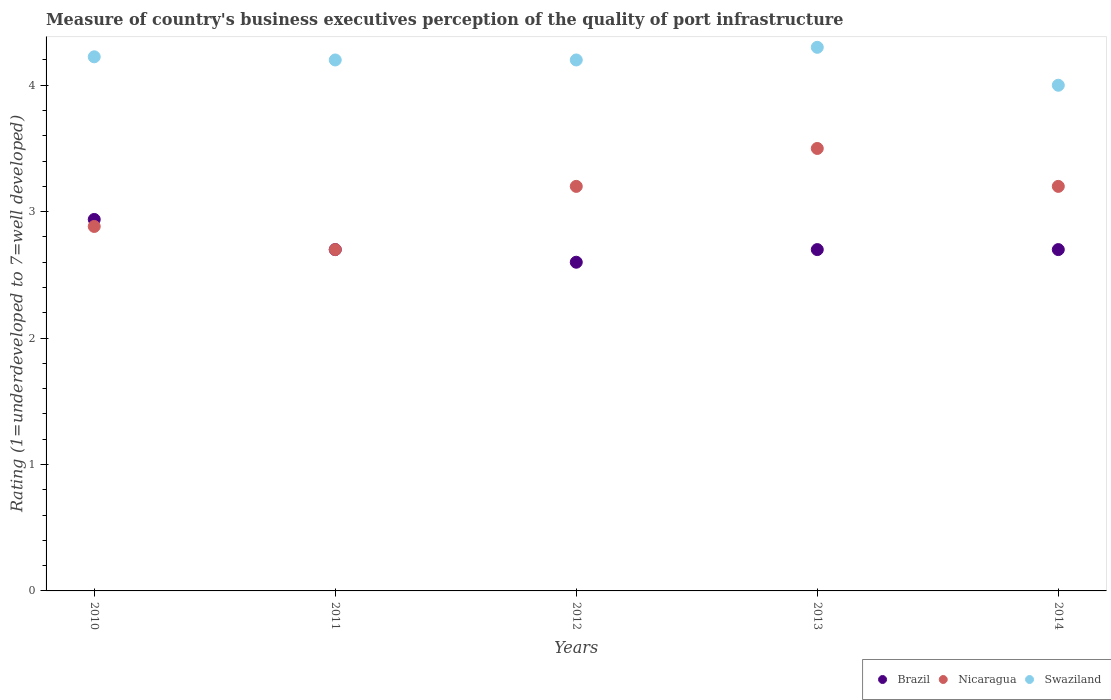How many different coloured dotlines are there?
Your response must be concise. 3. What is the ratings of the quality of port infrastructure in Brazil in 2011?
Offer a very short reply. 2.7. Across all years, what is the maximum ratings of the quality of port infrastructure in Brazil?
Provide a short and direct response. 2.94. In which year was the ratings of the quality of port infrastructure in Brazil minimum?
Ensure brevity in your answer.  2012. What is the total ratings of the quality of port infrastructure in Nicaragua in the graph?
Ensure brevity in your answer.  15.48. What is the difference between the ratings of the quality of port infrastructure in Swaziland in 2011 and that in 2013?
Make the answer very short. -0.1. What is the average ratings of the quality of port infrastructure in Brazil per year?
Your answer should be compact. 2.73. In the year 2011, what is the difference between the ratings of the quality of port infrastructure in Swaziland and ratings of the quality of port infrastructure in Brazil?
Make the answer very short. 1.5. Is the difference between the ratings of the quality of port infrastructure in Swaziland in 2011 and 2014 greater than the difference between the ratings of the quality of port infrastructure in Brazil in 2011 and 2014?
Your answer should be compact. Yes. What is the difference between the highest and the second highest ratings of the quality of port infrastructure in Brazil?
Make the answer very short. 0.24. What is the difference between the highest and the lowest ratings of the quality of port infrastructure in Swaziland?
Give a very brief answer. 0.3. Is it the case that in every year, the sum of the ratings of the quality of port infrastructure in Brazil and ratings of the quality of port infrastructure in Swaziland  is greater than the ratings of the quality of port infrastructure in Nicaragua?
Provide a succinct answer. Yes. Is the ratings of the quality of port infrastructure in Brazil strictly greater than the ratings of the quality of port infrastructure in Swaziland over the years?
Offer a very short reply. No. How many dotlines are there?
Keep it short and to the point. 3. How many years are there in the graph?
Your answer should be compact. 5. How many legend labels are there?
Provide a short and direct response. 3. How are the legend labels stacked?
Offer a very short reply. Horizontal. What is the title of the graph?
Your response must be concise. Measure of country's business executives perception of the quality of port infrastructure. What is the label or title of the X-axis?
Keep it short and to the point. Years. What is the label or title of the Y-axis?
Make the answer very short. Rating (1=underdeveloped to 7=well developed). What is the Rating (1=underdeveloped to 7=well developed) of Brazil in 2010?
Make the answer very short. 2.94. What is the Rating (1=underdeveloped to 7=well developed) of Nicaragua in 2010?
Keep it short and to the point. 2.88. What is the Rating (1=underdeveloped to 7=well developed) in Swaziland in 2010?
Your response must be concise. 4.23. What is the Rating (1=underdeveloped to 7=well developed) in Brazil in 2012?
Keep it short and to the point. 2.6. What is the Rating (1=underdeveloped to 7=well developed) in Nicaragua in 2012?
Ensure brevity in your answer.  3.2. What is the Rating (1=underdeveloped to 7=well developed) in Swaziland in 2012?
Offer a terse response. 4.2. What is the Rating (1=underdeveloped to 7=well developed) of Brazil in 2014?
Offer a terse response. 2.7. Across all years, what is the maximum Rating (1=underdeveloped to 7=well developed) in Brazil?
Give a very brief answer. 2.94. Across all years, what is the maximum Rating (1=underdeveloped to 7=well developed) in Nicaragua?
Your response must be concise. 3.5. Across all years, what is the minimum Rating (1=underdeveloped to 7=well developed) in Nicaragua?
Give a very brief answer. 2.7. What is the total Rating (1=underdeveloped to 7=well developed) in Brazil in the graph?
Your answer should be very brief. 13.64. What is the total Rating (1=underdeveloped to 7=well developed) in Nicaragua in the graph?
Your answer should be compact. 15.48. What is the total Rating (1=underdeveloped to 7=well developed) in Swaziland in the graph?
Keep it short and to the point. 20.93. What is the difference between the Rating (1=underdeveloped to 7=well developed) in Brazil in 2010 and that in 2011?
Offer a very short reply. 0.24. What is the difference between the Rating (1=underdeveloped to 7=well developed) of Nicaragua in 2010 and that in 2011?
Give a very brief answer. 0.18. What is the difference between the Rating (1=underdeveloped to 7=well developed) in Swaziland in 2010 and that in 2011?
Offer a very short reply. 0.03. What is the difference between the Rating (1=underdeveloped to 7=well developed) in Brazil in 2010 and that in 2012?
Provide a succinct answer. 0.34. What is the difference between the Rating (1=underdeveloped to 7=well developed) in Nicaragua in 2010 and that in 2012?
Offer a terse response. -0.32. What is the difference between the Rating (1=underdeveloped to 7=well developed) in Swaziland in 2010 and that in 2012?
Your answer should be very brief. 0.03. What is the difference between the Rating (1=underdeveloped to 7=well developed) of Brazil in 2010 and that in 2013?
Keep it short and to the point. 0.24. What is the difference between the Rating (1=underdeveloped to 7=well developed) of Nicaragua in 2010 and that in 2013?
Offer a very short reply. -0.62. What is the difference between the Rating (1=underdeveloped to 7=well developed) of Swaziland in 2010 and that in 2013?
Provide a succinct answer. -0.07. What is the difference between the Rating (1=underdeveloped to 7=well developed) of Brazil in 2010 and that in 2014?
Provide a short and direct response. 0.24. What is the difference between the Rating (1=underdeveloped to 7=well developed) in Nicaragua in 2010 and that in 2014?
Your answer should be very brief. -0.32. What is the difference between the Rating (1=underdeveloped to 7=well developed) in Swaziland in 2010 and that in 2014?
Your answer should be very brief. 0.23. What is the difference between the Rating (1=underdeveloped to 7=well developed) in Swaziland in 2011 and that in 2012?
Provide a short and direct response. 0. What is the difference between the Rating (1=underdeveloped to 7=well developed) of Brazil in 2011 and that in 2013?
Offer a terse response. 0. What is the difference between the Rating (1=underdeveloped to 7=well developed) of Brazil in 2011 and that in 2014?
Make the answer very short. 0. What is the difference between the Rating (1=underdeveloped to 7=well developed) of Swaziland in 2011 and that in 2014?
Give a very brief answer. 0.2. What is the difference between the Rating (1=underdeveloped to 7=well developed) in Brazil in 2012 and that in 2013?
Make the answer very short. -0.1. What is the difference between the Rating (1=underdeveloped to 7=well developed) of Nicaragua in 2012 and that in 2013?
Give a very brief answer. -0.3. What is the difference between the Rating (1=underdeveloped to 7=well developed) of Swaziland in 2012 and that in 2013?
Your answer should be very brief. -0.1. What is the difference between the Rating (1=underdeveloped to 7=well developed) of Brazil in 2012 and that in 2014?
Offer a terse response. -0.1. What is the difference between the Rating (1=underdeveloped to 7=well developed) in Swaziland in 2012 and that in 2014?
Offer a very short reply. 0.2. What is the difference between the Rating (1=underdeveloped to 7=well developed) in Brazil in 2010 and the Rating (1=underdeveloped to 7=well developed) in Nicaragua in 2011?
Your answer should be very brief. 0.24. What is the difference between the Rating (1=underdeveloped to 7=well developed) of Brazil in 2010 and the Rating (1=underdeveloped to 7=well developed) of Swaziland in 2011?
Give a very brief answer. -1.26. What is the difference between the Rating (1=underdeveloped to 7=well developed) of Nicaragua in 2010 and the Rating (1=underdeveloped to 7=well developed) of Swaziland in 2011?
Provide a short and direct response. -1.32. What is the difference between the Rating (1=underdeveloped to 7=well developed) in Brazil in 2010 and the Rating (1=underdeveloped to 7=well developed) in Nicaragua in 2012?
Ensure brevity in your answer.  -0.26. What is the difference between the Rating (1=underdeveloped to 7=well developed) in Brazil in 2010 and the Rating (1=underdeveloped to 7=well developed) in Swaziland in 2012?
Provide a short and direct response. -1.26. What is the difference between the Rating (1=underdeveloped to 7=well developed) in Nicaragua in 2010 and the Rating (1=underdeveloped to 7=well developed) in Swaziland in 2012?
Your response must be concise. -1.32. What is the difference between the Rating (1=underdeveloped to 7=well developed) of Brazil in 2010 and the Rating (1=underdeveloped to 7=well developed) of Nicaragua in 2013?
Ensure brevity in your answer.  -0.56. What is the difference between the Rating (1=underdeveloped to 7=well developed) of Brazil in 2010 and the Rating (1=underdeveloped to 7=well developed) of Swaziland in 2013?
Provide a short and direct response. -1.36. What is the difference between the Rating (1=underdeveloped to 7=well developed) in Nicaragua in 2010 and the Rating (1=underdeveloped to 7=well developed) in Swaziland in 2013?
Your answer should be very brief. -1.42. What is the difference between the Rating (1=underdeveloped to 7=well developed) in Brazil in 2010 and the Rating (1=underdeveloped to 7=well developed) in Nicaragua in 2014?
Make the answer very short. -0.26. What is the difference between the Rating (1=underdeveloped to 7=well developed) of Brazil in 2010 and the Rating (1=underdeveloped to 7=well developed) of Swaziland in 2014?
Your answer should be very brief. -1.06. What is the difference between the Rating (1=underdeveloped to 7=well developed) of Nicaragua in 2010 and the Rating (1=underdeveloped to 7=well developed) of Swaziland in 2014?
Keep it short and to the point. -1.12. What is the difference between the Rating (1=underdeveloped to 7=well developed) in Nicaragua in 2011 and the Rating (1=underdeveloped to 7=well developed) in Swaziland in 2012?
Give a very brief answer. -1.5. What is the difference between the Rating (1=underdeveloped to 7=well developed) of Brazil in 2011 and the Rating (1=underdeveloped to 7=well developed) of Swaziland in 2013?
Provide a succinct answer. -1.6. What is the difference between the Rating (1=underdeveloped to 7=well developed) in Nicaragua in 2011 and the Rating (1=underdeveloped to 7=well developed) in Swaziland in 2013?
Make the answer very short. -1.6. What is the difference between the Rating (1=underdeveloped to 7=well developed) of Brazil in 2011 and the Rating (1=underdeveloped to 7=well developed) of Nicaragua in 2014?
Offer a terse response. -0.5. What is the difference between the Rating (1=underdeveloped to 7=well developed) of Brazil in 2012 and the Rating (1=underdeveloped to 7=well developed) of Nicaragua in 2013?
Offer a very short reply. -0.9. What is the difference between the Rating (1=underdeveloped to 7=well developed) of Brazil in 2012 and the Rating (1=underdeveloped to 7=well developed) of Nicaragua in 2014?
Keep it short and to the point. -0.6. What is the difference between the Rating (1=underdeveloped to 7=well developed) in Brazil in 2012 and the Rating (1=underdeveloped to 7=well developed) in Swaziland in 2014?
Keep it short and to the point. -1.4. What is the difference between the Rating (1=underdeveloped to 7=well developed) of Nicaragua in 2012 and the Rating (1=underdeveloped to 7=well developed) of Swaziland in 2014?
Offer a terse response. -0.8. What is the difference between the Rating (1=underdeveloped to 7=well developed) in Brazil in 2013 and the Rating (1=underdeveloped to 7=well developed) in Swaziland in 2014?
Offer a terse response. -1.3. What is the difference between the Rating (1=underdeveloped to 7=well developed) of Nicaragua in 2013 and the Rating (1=underdeveloped to 7=well developed) of Swaziland in 2014?
Your answer should be compact. -0.5. What is the average Rating (1=underdeveloped to 7=well developed) in Brazil per year?
Ensure brevity in your answer.  2.73. What is the average Rating (1=underdeveloped to 7=well developed) in Nicaragua per year?
Ensure brevity in your answer.  3.1. What is the average Rating (1=underdeveloped to 7=well developed) of Swaziland per year?
Offer a very short reply. 4.18. In the year 2010, what is the difference between the Rating (1=underdeveloped to 7=well developed) in Brazil and Rating (1=underdeveloped to 7=well developed) in Nicaragua?
Provide a succinct answer. 0.06. In the year 2010, what is the difference between the Rating (1=underdeveloped to 7=well developed) of Brazil and Rating (1=underdeveloped to 7=well developed) of Swaziland?
Keep it short and to the point. -1.29. In the year 2010, what is the difference between the Rating (1=underdeveloped to 7=well developed) in Nicaragua and Rating (1=underdeveloped to 7=well developed) in Swaziland?
Your answer should be compact. -1.34. In the year 2012, what is the difference between the Rating (1=underdeveloped to 7=well developed) of Brazil and Rating (1=underdeveloped to 7=well developed) of Nicaragua?
Give a very brief answer. -0.6. In the year 2012, what is the difference between the Rating (1=underdeveloped to 7=well developed) of Brazil and Rating (1=underdeveloped to 7=well developed) of Swaziland?
Offer a terse response. -1.6. In the year 2014, what is the difference between the Rating (1=underdeveloped to 7=well developed) in Nicaragua and Rating (1=underdeveloped to 7=well developed) in Swaziland?
Ensure brevity in your answer.  -0.8. What is the ratio of the Rating (1=underdeveloped to 7=well developed) of Brazil in 2010 to that in 2011?
Keep it short and to the point. 1.09. What is the ratio of the Rating (1=underdeveloped to 7=well developed) in Nicaragua in 2010 to that in 2011?
Provide a short and direct response. 1.07. What is the ratio of the Rating (1=underdeveloped to 7=well developed) in Swaziland in 2010 to that in 2011?
Offer a terse response. 1.01. What is the ratio of the Rating (1=underdeveloped to 7=well developed) in Brazil in 2010 to that in 2012?
Your response must be concise. 1.13. What is the ratio of the Rating (1=underdeveloped to 7=well developed) in Nicaragua in 2010 to that in 2012?
Your response must be concise. 0.9. What is the ratio of the Rating (1=underdeveloped to 7=well developed) of Brazil in 2010 to that in 2013?
Keep it short and to the point. 1.09. What is the ratio of the Rating (1=underdeveloped to 7=well developed) in Nicaragua in 2010 to that in 2013?
Your response must be concise. 0.82. What is the ratio of the Rating (1=underdeveloped to 7=well developed) in Swaziland in 2010 to that in 2013?
Your answer should be very brief. 0.98. What is the ratio of the Rating (1=underdeveloped to 7=well developed) in Brazil in 2010 to that in 2014?
Keep it short and to the point. 1.09. What is the ratio of the Rating (1=underdeveloped to 7=well developed) of Nicaragua in 2010 to that in 2014?
Give a very brief answer. 0.9. What is the ratio of the Rating (1=underdeveloped to 7=well developed) in Swaziland in 2010 to that in 2014?
Make the answer very short. 1.06. What is the ratio of the Rating (1=underdeveloped to 7=well developed) of Brazil in 2011 to that in 2012?
Provide a short and direct response. 1.04. What is the ratio of the Rating (1=underdeveloped to 7=well developed) in Nicaragua in 2011 to that in 2012?
Your answer should be very brief. 0.84. What is the ratio of the Rating (1=underdeveloped to 7=well developed) of Swaziland in 2011 to that in 2012?
Offer a very short reply. 1. What is the ratio of the Rating (1=underdeveloped to 7=well developed) of Brazil in 2011 to that in 2013?
Your response must be concise. 1. What is the ratio of the Rating (1=underdeveloped to 7=well developed) in Nicaragua in 2011 to that in 2013?
Offer a terse response. 0.77. What is the ratio of the Rating (1=underdeveloped to 7=well developed) of Swaziland in 2011 to that in 2013?
Offer a terse response. 0.98. What is the ratio of the Rating (1=underdeveloped to 7=well developed) of Nicaragua in 2011 to that in 2014?
Your response must be concise. 0.84. What is the ratio of the Rating (1=underdeveloped to 7=well developed) in Swaziland in 2011 to that in 2014?
Offer a terse response. 1.05. What is the ratio of the Rating (1=underdeveloped to 7=well developed) in Brazil in 2012 to that in 2013?
Your answer should be very brief. 0.96. What is the ratio of the Rating (1=underdeveloped to 7=well developed) of Nicaragua in 2012 to that in 2013?
Make the answer very short. 0.91. What is the ratio of the Rating (1=underdeveloped to 7=well developed) of Swaziland in 2012 to that in 2013?
Your response must be concise. 0.98. What is the ratio of the Rating (1=underdeveloped to 7=well developed) in Brazil in 2013 to that in 2014?
Provide a short and direct response. 1. What is the ratio of the Rating (1=underdeveloped to 7=well developed) of Nicaragua in 2013 to that in 2014?
Give a very brief answer. 1.09. What is the ratio of the Rating (1=underdeveloped to 7=well developed) in Swaziland in 2013 to that in 2014?
Offer a very short reply. 1.07. What is the difference between the highest and the second highest Rating (1=underdeveloped to 7=well developed) of Brazil?
Provide a succinct answer. 0.24. What is the difference between the highest and the second highest Rating (1=underdeveloped to 7=well developed) of Swaziland?
Make the answer very short. 0.07. What is the difference between the highest and the lowest Rating (1=underdeveloped to 7=well developed) in Brazil?
Keep it short and to the point. 0.34. What is the difference between the highest and the lowest Rating (1=underdeveloped to 7=well developed) in Nicaragua?
Provide a succinct answer. 0.8. 